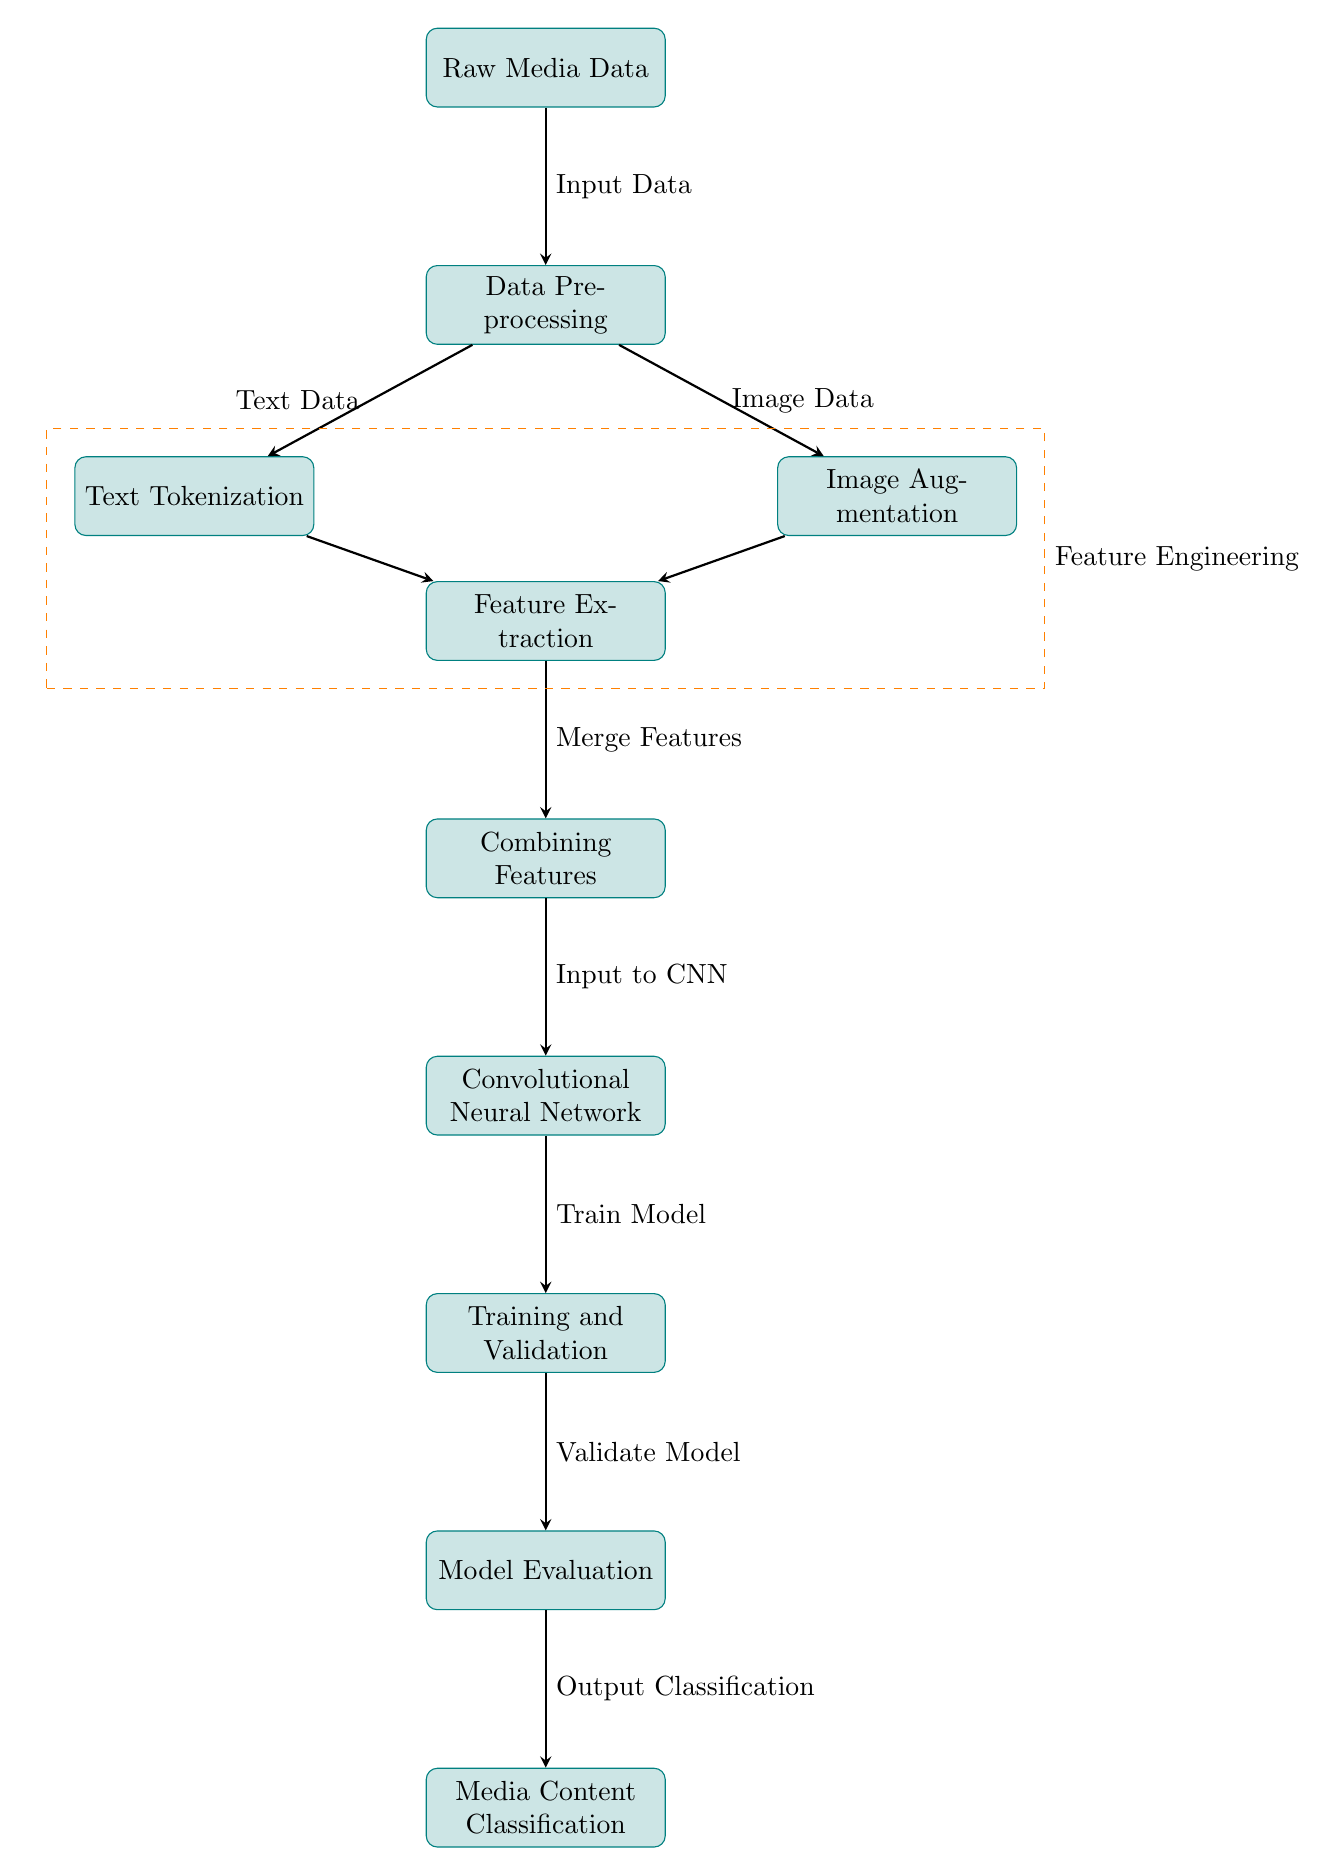What is the first node in the diagram? The first node, located at the top of the diagram, is labeled "Raw Media Data" and represents the initial input for the entire process.
Answer: Raw Media Data How many nodes are in the diagram? By counting from the top to the bottom of the diagram, there are ten individual nodes representing distinct processes or stages in the media content classification pipeline.
Answer: Ten What type of data is processed after "Data Preprocessing"? Following "Data Preprocessing," there are two branches. The left branch processes text data labeled "Text Data," and the right branch processes image data labeled "Image Data." Both types of data flow out of the preprocessing stage.
Answer: Text Data and Image Data What is combined in the "Combining Features" node? The "Combining Features" node merges results from both the text tokenization and image augmentation processes, consolidating them for further analysis in the Convolutional Neural Network (CNN).
Answer: Text Features and Image Features Which process follows "Model Evaluation"? After "Model Evaluation," the workflow proceeds directly to the "Media Content Classification" node, which is responsible for delivering the final output classification based on the evaluated model.
Answer: Media Content Classification What is the role of the "Convolutional Neural Network" node? The "Convolutional Neural Network" node is crucial as it receives the combined features input and trains the model based on those features, enabling effective classification of media content.
Answer: Train Model What is the purpose of the "Feature Engineering" box? The "Feature Engineering" box, which encompasses "Text Tokenization," "Image Augmentation," and "Feature Extraction," serves to enhance the raw data before it is inputted into the CNN, ensuring that the model has the best data possible for learning.
Answer: Enhance Data What is the final output of this diagram? The final output produced by the diagram after processing the input raw media data through various stages is the classification of the media content, as indicated by the last node, "Media Content Classification."
Answer: Output Classification What kind of node connects "Training and Validation" to "Model Evaluation"? The connection from "Training and Validation" to "Model Evaluation" is represented by an arrow, indicating a flow of information that signifies the need to evaluate the model after training.
Answer: Arrow Which two processes are performed simultaneously under "Data Preprocessing"? The processes of "Text Tokenization" and "Image Augmentation" occur concurrently under the "Data Preprocessing" stage, leading to the preparation of both text and image data.
Answer: Text Tokenization and Image Augmentation 